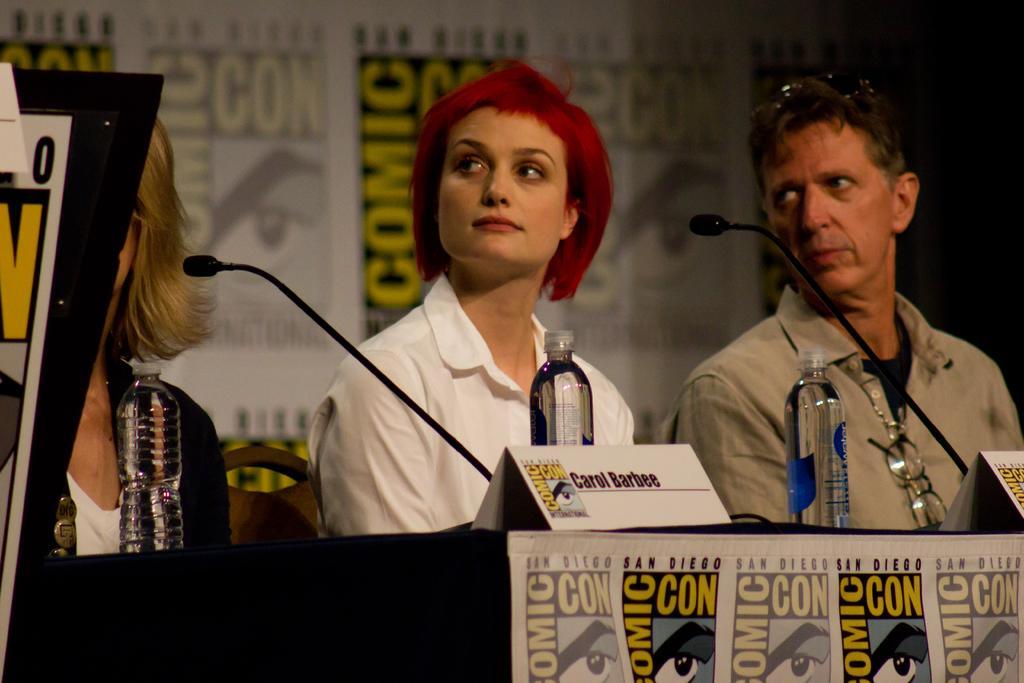How would you summarize this image in a sentence or two? In this image I can see a man and two women are sitting on chairs. I can also see few mics, few bottles and I can see comic con is written at many places. 